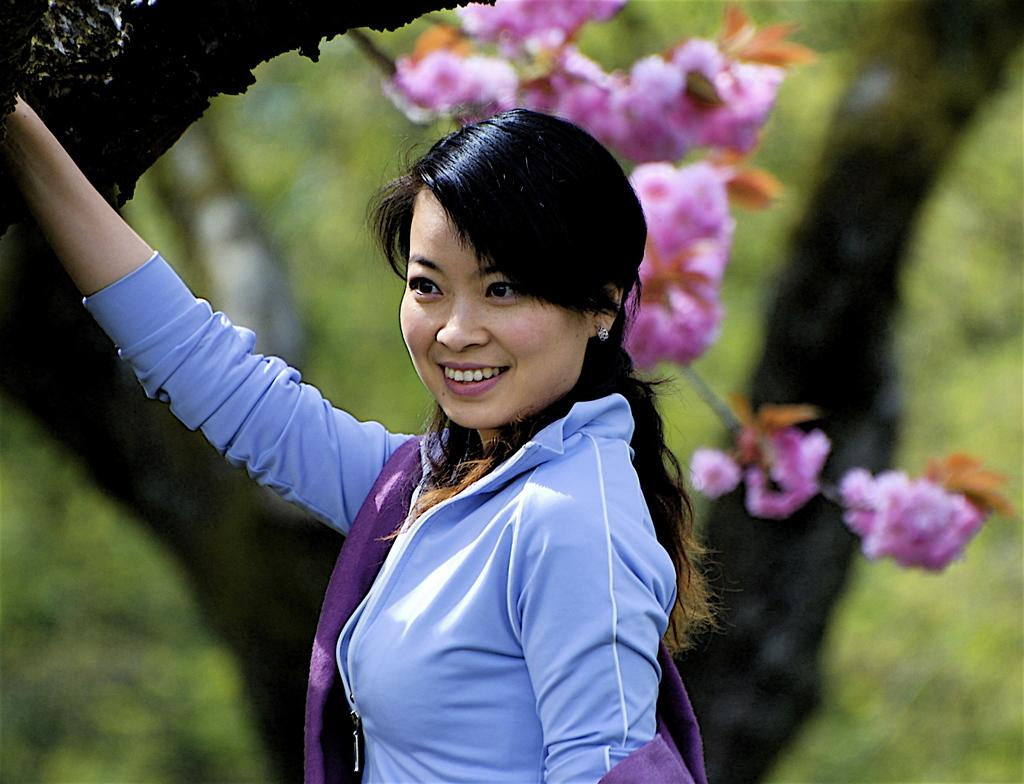What is the woman doing in the image? The woman is standing and smiling in the image. What type of plants can be seen in the image? There are flowers with stems in the image. What part of a tree is visible in the image? There is a tree trunk in the image. How would you describe the background of the image? The background of the image appears blurry. What type of prose is the woman reading in the image? There is no indication that the woman is reading any prose in the image. Can you see any worms crawling on the tree trunk in the image? There are no worms visible on the tree trunk in the image. 